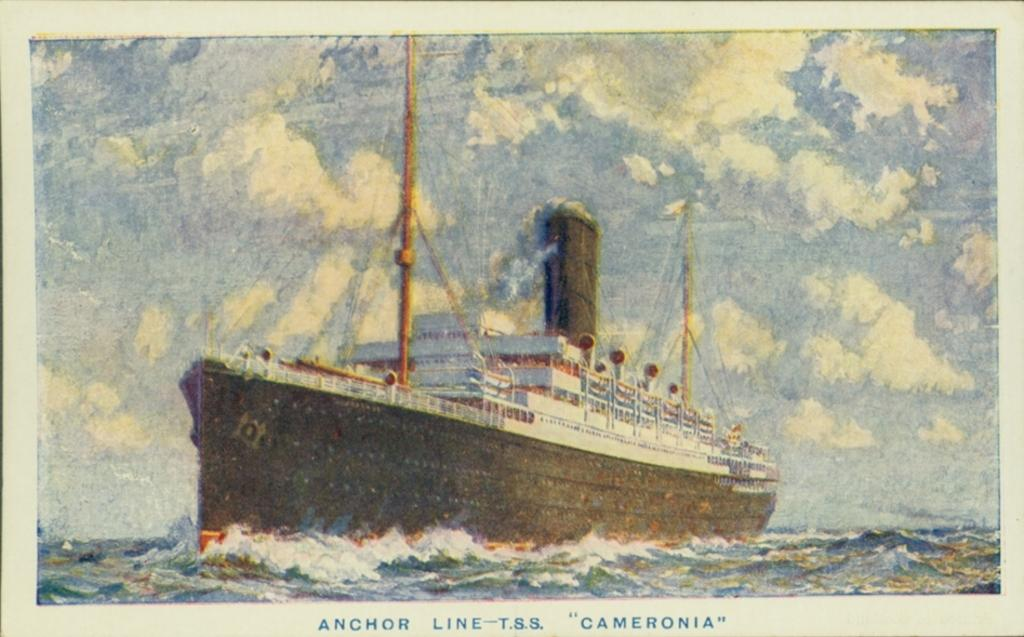What type of artwork is depicted in the image? The image is a painting. What is the main subject of the painting? There is a ship in the painting. What is the ship doing in the painting? The ship is sailing on water. How would you describe the weather in the painting? The sky in the painting is cloudy. Is there any text present in the image? Yes, there is text written on the image. How many people are in the crowd surrounding the ship in the painting? There is no crowd present in the painting; it only features a ship sailing on water. What type of lipstick is the porter wearing in the painting? There is no porter or lipstick present in the painting; it is a ship sailing on water with a cloudy sky. 